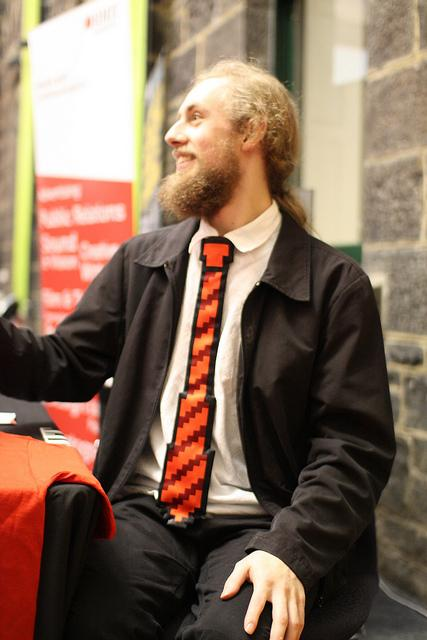What unusual design does his tie have? Please explain your reasoning. like pixels. Ties are usually formal. this tie looks like an old video game 